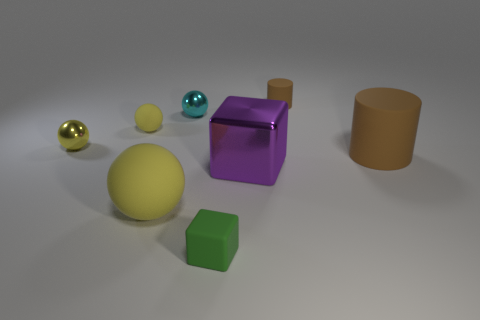Subtract all yellow spheres. How many spheres are left? 1 Subtract all cyan cylinders. How many yellow balls are left? 3 Subtract all cyan balls. How many balls are left? 3 Add 1 matte blocks. How many objects exist? 9 Subtract all green spheres. Subtract all yellow cylinders. How many spheres are left? 4 Add 3 balls. How many balls exist? 7 Subtract 0 brown spheres. How many objects are left? 8 Subtract all cubes. How many objects are left? 6 Subtract all tiny cyan shiny things. Subtract all matte objects. How many objects are left? 2 Add 8 cyan objects. How many cyan objects are left? 9 